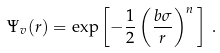Convert formula to latex. <formula><loc_0><loc_0><loc_500><loc_500>\Psi _ { v } ( r ) = \exp \left [ - \frac { 1 } { 2 } \left ( \frac { b \sigma } { r } \right ) ^ { n } \, \right ] \, .</formula> 